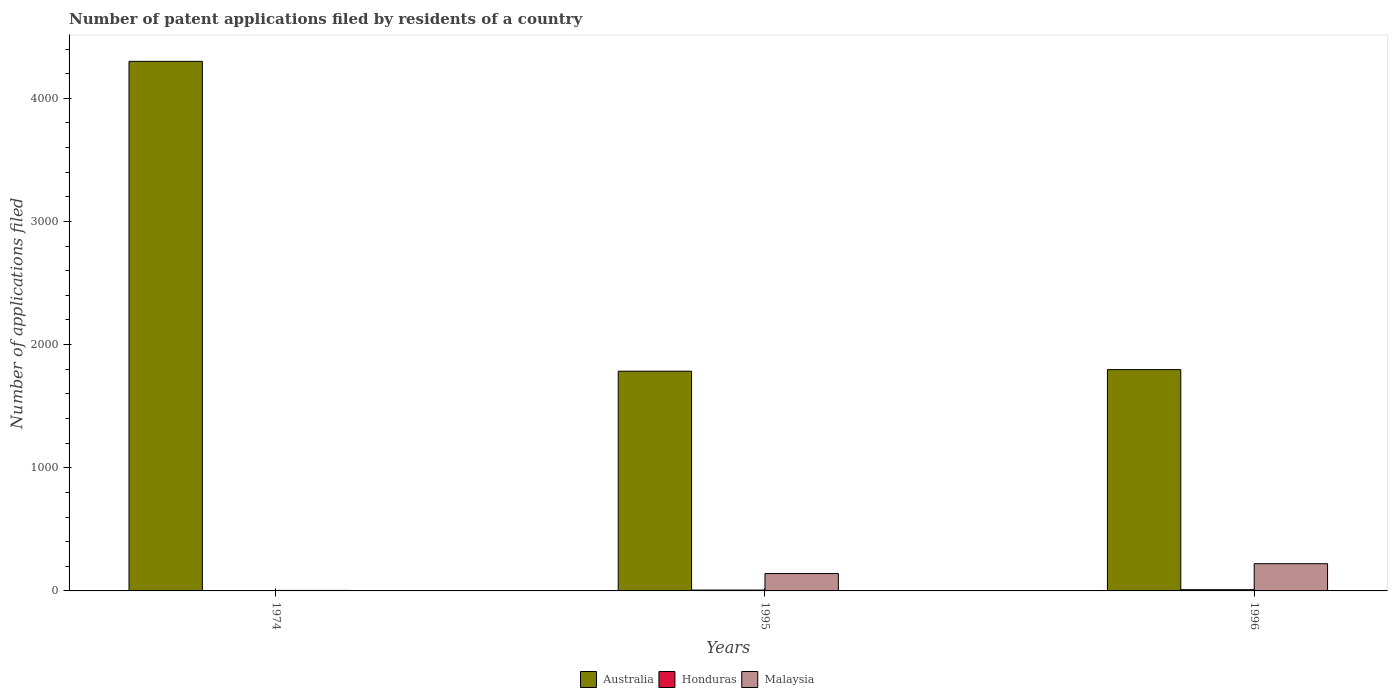How many groups of bars are there?
Provide a short and direct response. 3. Are the number of bars per tick equal to the number of legend labels?
Ensure brevity in your answer.  Yes. Are the number of bars on each tick of the X-axis equal?
Offer a terse response. Yes. How many bars are there on the 3rd tick from the left?
Offer a very short reply. 3. How many bars are there on the 3rd tick from the right?
Ensure brevity in your answer.  3. What is the label of the 1st group of bars from the left?
Ensure brevity in your answer.  1974. In how many cases, is the number of bars for a given year not equal to the number of legend labels?
Offer a very short reply. 0. Across all years, what is the maximum number of applications filed in Malaysia?
Your answer should be very brief. 221. Across all years, what is the minimum number of applications filed in Australia?
Your answer should be compact. 1784. In which year was the number of applications filed in Malaysia maximum?
Your answer should be very brief. 1996. In which year was the number of applications filed in Malaysia minimum?
Offer a very short reply. 1974. What is the total number of applications filed in Malaysia in the graph?
Your answer should be compact. 366. What is the difference between the number of applications filed in Malaysia in 1996 and the number of applications filed in Australia in 1995?
Your answer should be compact. -1563. What is the average number of applications filed in Australia per year?
Ensure brevity in your answer.  2627. In the year 1996, what is the difference between the number of applications filed in Australia and number of applications filed in Honduras?
Your answer should be very brief. 1787. In how many years, is the number of applications filed in Honduras greater than 3000?
Offer a very short reply. 0. What is the ratio of the number of applications filed in Australia in 1974 to that in 1995?
Offer a very short reply. 2.41. What is the difference between the highest and the second highest number of applications filed in Australia?
Your response must be concise. 2503. What is the difference between the highest and the lowest number of applications filed in Australia?
Offer a terse response. 2516. In how many years, is the number of applications filed in Australia greater than the average number of applications filed in Australia taken over all years?
Offer a very short reply. 1. What does the 1st bar from the left in 1996 represents?
Give a very brief answer. Australia. What does the 3rd bar from the right in 1974 represents?
Your response must be concise. Australia. How many bars are there?
Give a very brief answer. 9. Are all the bars in the graph horizontal?
Offer a very short reply. No. What is the difference between two consecutive major ticks on the Y-axis?
Your answer should be compact. 1000. Does the graph contain any zero values?
Your answer should be compact. No. Where does the legend appear in the graph?
Provide a succinct answer. Bottom center. What is the title of the graph?
Offer a very short reply. Number of patent applications filed by residents of a country. What is the label or title of the X-axis?
Your answer should be very brief. Years. What is the label or title of the Y-axis?
Offer a terse response. Number of applications filed. What is the Number of applications filed of Australia in 1974?
Provide a short and direct response. 4300. What is the Number of applications filed in Australia in 1995?
Offer a very short reply. 1784. What is the Number of applications filed in Honduras in 1995?
Your answer should be compact. 7. What is the Number of applications filed of Malaysia in 1995?
Ensure brevity in your answer.  141. What is the Number of applications filed of Australia in 1996?
Provide a succinct answer. 1797. What is the Number of applications filed in Malaysia in 1996?
Provide a short and direct response. 221. Across all years, what is the maximum Number of applications filed in Australia?
Provide a short and direct response. 4300. Across all years, what is the maximum Number of applications filed in Honduras?
Provide a short and direct response. 10. Across all years, what is the maximum Number of applications filed of Malaysia?
Your answer should be compact. 221. Across all years, what is the minimum Number of applications filed in Australia?
Offer a terse response. 1784. Across all years, what is the minimum Number of applications filed of Honduras?
Offer a terse response. 1. Across all years, what is the minimum Number of applications filed in Malaysia?
Ensure brevity in your answer.  4. What is the total Number of applications filed of Australia in the graph?
Offer a terse response. 7881. What is the total Number of applications filed of Honduras in the graph?
Your response must be concise. 18. What is the total Number of applications filed in Malaysia in the graph?
Keep it short and to the point. 366. What is the difference between the Number of applications filed in Australia in 1974 and that in 1995?
Provide a succinct answer. 2516. What is the difference between the Number of applications filed in Malaysia in 1974 and that in 1995?
Provide a short and direct response. -137. What is the difference between the Number of applications filed of Australia in 1974 and that in 1996?
Keep it short and to the point. 2503. What is the difference between the Number of applications filed in Malaysia in 1974 and that in 1996?
Your answer should be very brief. -217. What is the difference between the Number of applications filed of Australia in 1995 and that in 1996?
Give a very brief answer. -13. What is the difference between the Number of applications filed in Honduras in 1995 and that in 1996?
Provide a succinct answer. -3. What is the difference between the Number of applications filed of Malaysia in 1995 and that in 1996?
Provide a succinct answer. -80. What is the difference between the Number of applications filed of Australia in 1974 and the Number of applications filed of Honduras in 1995?
Ensure brevity in your answer.  4293. What is the difference between the Number of applications filed of Australia in 1974 and the Number of applications filed of Malaysia in 1995?
Make the answer very short. 4159. What is the difference between the Number of applications filed of Honduras in 1974 and the Number of applications filed of Malaysia in 1995?
Your answer should be compact. -140. What is the difference between the Number of applications filed in Australia in 1974 and the Number of applications filed in Honduras in 1996?
Your response must be concise. 4290. What is the difference between the Number of applications filed in Australia in 1974 and the Number of applications filed in Malaysia in 1996?
Offer a terse response. 4079. What is the difference between the Number of applications filed of Honduras in 1974 and the Number of applications filed of Malaysia in 1996?
Offer a terse response. -220. What is the difference between the Number of applications filed in Australia in 1995 and the Number of applications filed in Honduras in 1996?
Your answer should be very brief. 1774. What is the difference between the Number of applications filed of Australia in 1995 and the Number of applications filed of Malaysia in 1996?
Keep it short and to the point. 1563. What is the difference between the Number of applications filed in Honduras in 1995 and the Number of applications filed in Malaysia in 1996?
Give a very brief answer. -214. What is the average Number of applications filed of Australia per year?
Ensure brevity in your answer.  2627. What is the average Number of applications filed in Honduras per year?
Offer a terse response. 6. What is the average Number of applications filed of Malaysia per year?
Your answer should be compact. 122. In the year 1974, what is the difference between the Number of applications filed in Australia and Number of applications filed in Honduras?
Provide a short and direct response. 4299. In the year 1974, what is the difference between the Number of applications filed of Australia and Number of applications filed of Malaysia?
Provide a succinct answer. 4296. In the year 1995, what is the difference between the Number of applications filed in Australia and Number of applications filed in Honduras?
Provide a short and direct response. 1777. In the year 1995, what is the difference between the Number of applications filed of Australia and Number of applications filed of Malaysia?
Your answer should be very brief. 1643. In the year 1995, what is the difference between the Number of applications filed of Honduras and Number of applications filed of Malaysia?
Offer a very short reply. -134. In the year 1996, what is the difference between the Number of applications filed in Australia and Number of applications filed in Honduras?
Ensure brevity in your answer.  1787. In the year 1996, what is the difference between the Number of applications filed of Australia and Number of applications filed of Malaysia?
Provide a short and direct response. 1576. In the year 1996, what is the difference between the Number of applications filed in Honduras and Number of applications filed in Malaysia?
Make the answer very short. -211. What is the ratio of the Number of applications filed of Australia in 1974 to that in 1995?
Your answer should be compact. 2.41. What is the ratio of the Number of applications filed of Honduras in 1974 to that in 1995?
Keep it short and to the point. 0.14. What is the ratio of the Number of applications filed of Malaysia in 1974 to that in 1995?
Provide a succinct answer. 0.03. What is the ratio of the Number of applications filed of Australia in 1974 to that in 1996?
Your answer should be very brief. 2.39. What is the ratio of the Number of applications filed in Malaysia in 1974 to that in 1996?
Make the answer very short. 0.02. What is the ratio of the Number of applications filed in Malaysia in 1995 to that in 1996?
Provide a succinct answer. 0.64. What is the difference between the highest and the second highest Number of applications filed of Australia?
Provide a succinct answer. 2503. What is the difference between the highest and the second highest Number of applications filed in Honduras?
Your answer should be very brief. 3. What is the difference between the highest and the lowest Number of applications filed in Australia?
Ensure brevity in your answer.  2516. What is the difference between the highest and the lowest Number of applications filed of Honduras?
Keep it short and to the point. 9. What is the difference between the highest and the lowest Number of applications filed of Malaysia?
Provide a short and direct response. 217. 